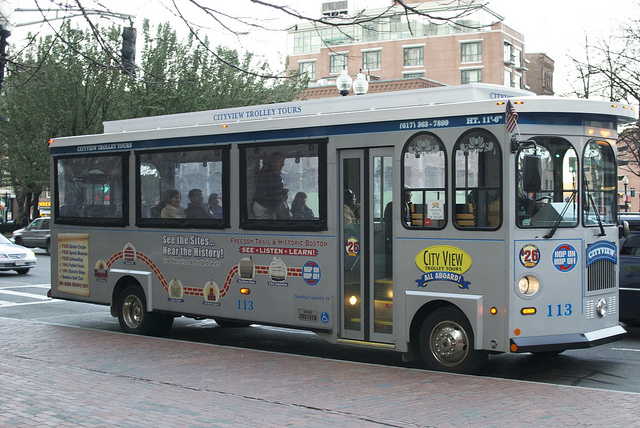<image>What country is this trolley driving in? It's ambiguous to determine the country this trolley is driving in. It could be USA, Canada, Britain or others. What country is this trolley driving in? It is ambiguous what country the trolley is driving in. It could be London, San Francisco, USA or Canada. 